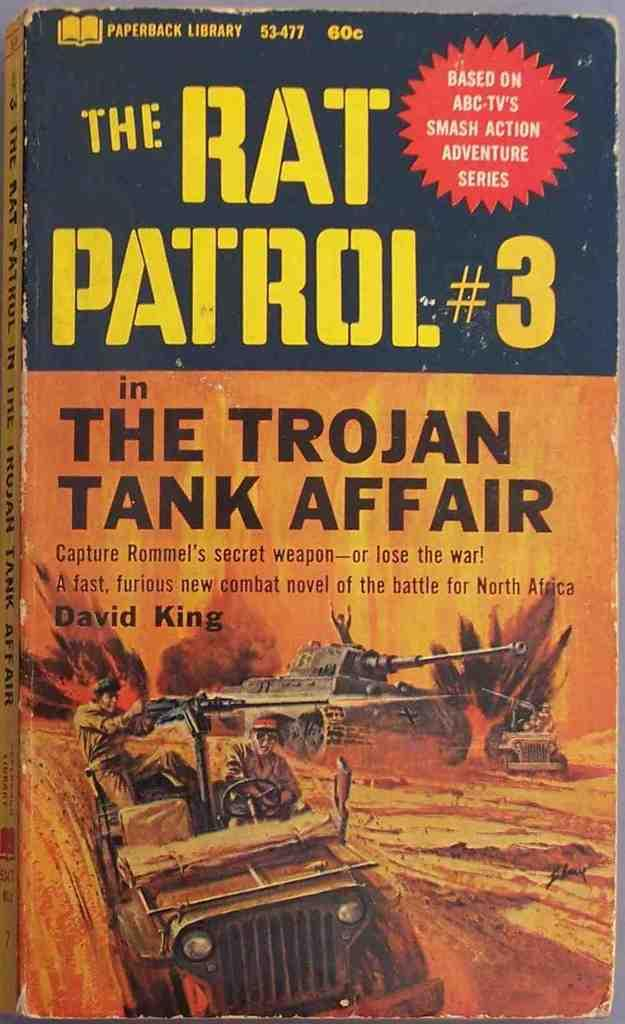What object is present in the image that is related to reading? There is a book in the image. What type of images are on the book? The book has a picture of an army tank and jeeps on it. What theme might the book be about based on the images? The images suggest that the book is about a war scene. What is written above the image on the book? There is text above the image on the book. Where can you buy the book in the image? The image does not provide information about where to buy the book. What type of airplane is flying over the war scene in the image? There is no airplane present in the image; it depicts a war scene with army tanks and jeeps. 